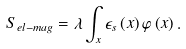Convert formula to latex. <formula><loc_0><loc_0><loc_500><loc_500>S _ { e l - m a g } = \lambda \int _ { x } \epsilon _ { s } \left ( x \right ) \varphi \left ( x \right ) .</formula> 